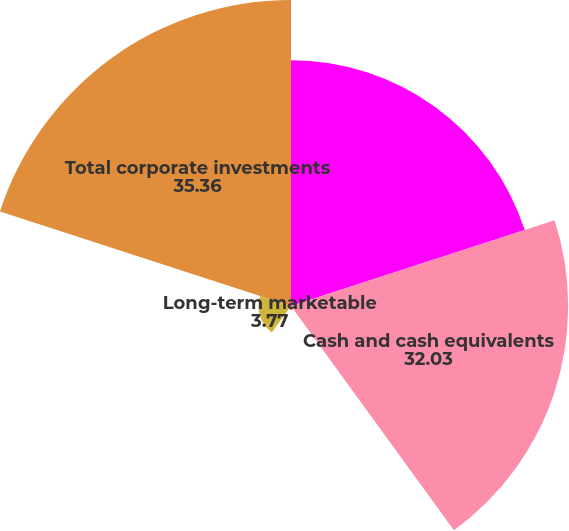Convert chart to OTSL. <chart><loc_0><loc_0><loc_500><loc_500><pie_chart><fcel>June 30<fcel>Cash and cash equivalents<fcel>Short-term marketable<fcel>Long-term marketable<fcel>Total corporate investments<nl><fcel>28.4%<fcel>32.03%<fcel>0.44%<fcel>3.77%<fcel>35.36%<nl></chart> 